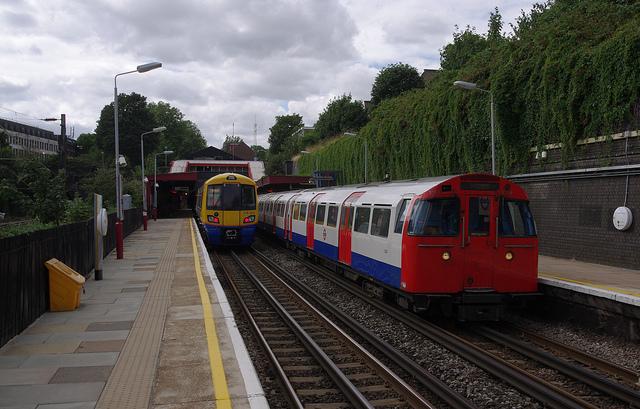What are the trains doing?
Quick response, please. Sitting. What is on the other side of the wall?
Write a very short answer. Trees. Are the trains pulling out of the station?
Keep it brief. Yes. How many trains are in this Picture?
Give a very brief answer. 2. Are people waiting for the train?
Give a very brief answer. No. Which train has white lights?
Concise answer only. Right one. 